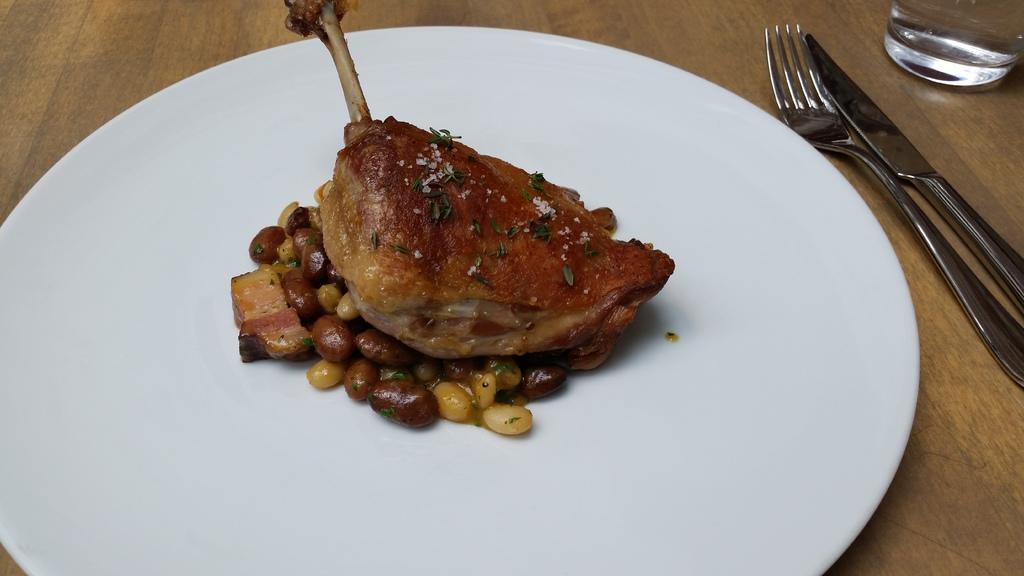What is on the plate that is visible in the image? There is a food item on the plate in the image. What utensils are visible in the image? There is a fork and a dinner knife visible in the image. What else can be seen on the table in the image? There is a glass on the table in the image. Where are all these items located? All of these items are on a table in the image. What type of notebook is being used to write on the table in the image? There is no notebook present in the image; it only features a plate with a food item, a fork, a dinner knife, and a glass on a table. 